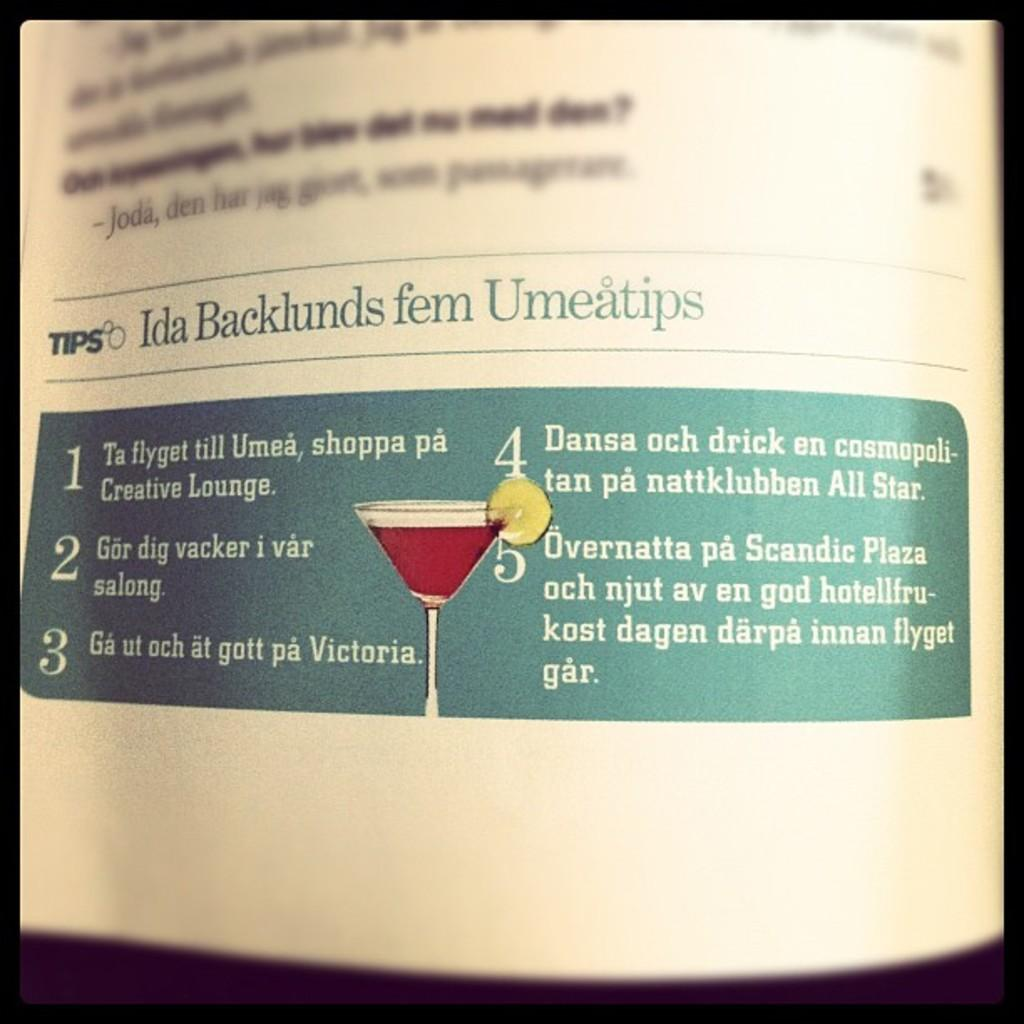<image>
Provide a brief description of the given image. A magazine's tips start with one about the Creative Lounge. 